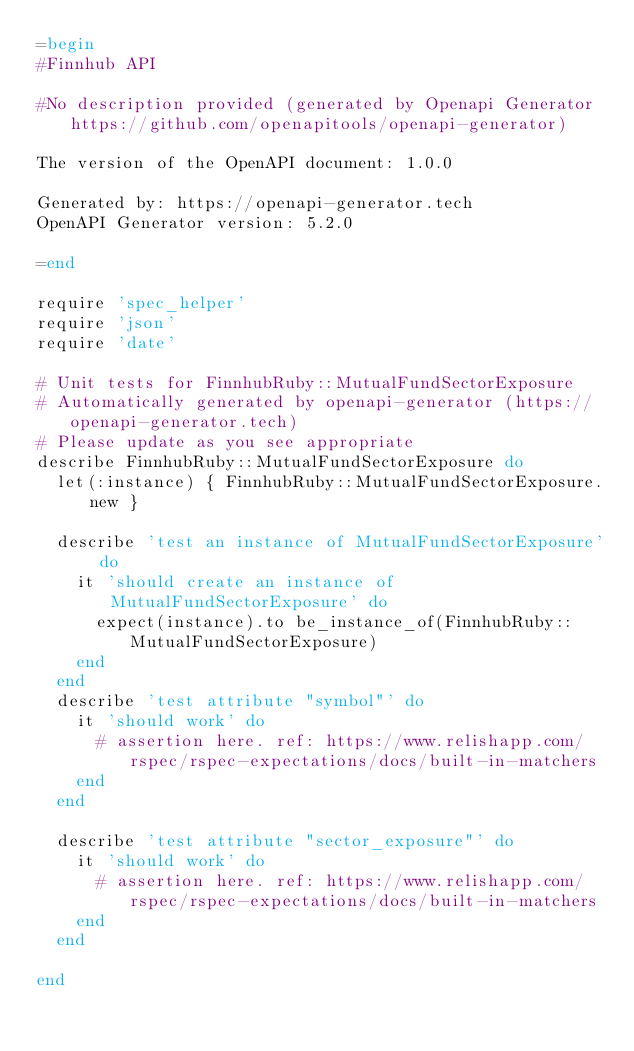<code> <loc_0><loc_0><loc_500><loc_500><_Ruby_>=begin
#Finnhub API

#No description provided (generated by Openapi Generator https://github.com/openapitools/openapi-generator)

The version of the OpenAPI document: 1.0.0

Generated by: https://openapi-generator.tech
OpenAPI Generator version: 5.2.0

=end

require 'spec_helper'
require 'json'
require 'date'

# Unit tests for FinnhubRuby::MutualFundSectorExposure
# Automatically generated by openapi-generator (https://openapi-generator.tech)
# Please update as you see appropriate
describe FinnhubRuby::MutualFundSectorExposure do
  let(:instance) { FinnhubRuby::MutualFundSectorExposure.new }

  describe 'test an instance of MutualFundSectorExposure' do
    it 'should create an instance of MutualFundSectorExposure' do
      expect(instance).to be_instance_of(FinnhubRuby::MutualFundSectorExposure)
    end
  end
  describe 'test attribute "symbol"' do
    it 'should work' do
      # assertion here. ref: https://www.relishapp.com/rspec/rspec-expectations/docs/built-in-matchers
    end
  end

  describe 'test attribute "sector_exposure"' do
    it 'should work' do
      # assertion here. ref: https://www.relishapp.com/rspec/rspec-expectations/docs/built-in-matchers
    end
  end

end
</code> 